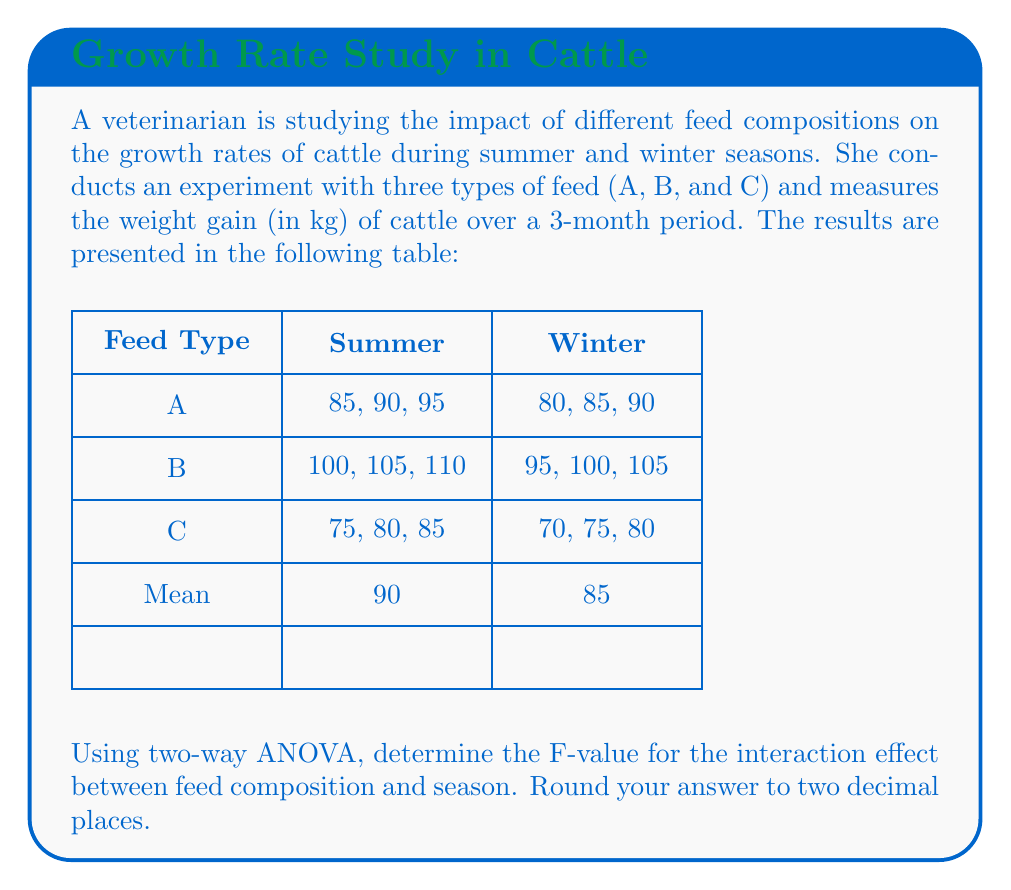Could you help me with this problem? Let's approach this step-by-step:

1) First, we need to calculate the sum of squares for the interaction (SS_int):

   $$SS_{int} = SS_{total} - SS_{A} - SS_{B} - SS_{within}$$

   Where A is Feed Type and B is Season.

2) Calculate the total sum of squares (SS_total):
   $$SS_{total} = \sum (x_{ijk} - \bar{x})^2$$
   
   Grand mean $\bar{x} = 87.5$

   $$SS_{total} = (85-87.5)^2 + (90-87.5)^2 + ... + (80-87.5)^2 = 2137.5$$

3) Calculate sum of squares for Feed Type (SS_A):
   $$SS_A = n_j \sum_j (\bar{x_j} - \bar{x})^2$$
   
   Where $n_j = 6$ (3 replications * 2 seasons)
   
   $$SS_A = 6[(87.5-87.5)^2 + (102.5-87.5)^2 + (77.5-87.5)^2] = 1875$$

4) Calculate sum of squares for Season (SS_B):
   $$SS_B = n_i \sum_i (\bar{x_i} - \bar{x})^2$$
   
   Where $n_i = 9$ (3 feed types * 3 replications)
   
   $$SS_B = 9[(90-87.5)^2 + (85-87.5)^2] = 225$$

5) Calculate sum of squares within groups (SS_within):
   $$SS_{within} = \sum (x_{ijk} - \bar{x_{ij}})^2$$
   
   $$SS_{within} = [(85-90)^2 + (90-90)^2 + (95-90)^2] + ... + [(70-75)^2 + (75-75)^2 + (80-75)^2] = 150$$

6) Now we can calculate SS_int:
   $$SS_{int} = 2137.5 - 1875 - 225 - 150 = -112.5$$

7) The degrees of freedom for interaction is:
   $$df_{int} = (a-1)(b-1) = (3-1)(2-1) = 2$$

8) Mean Square for interaction:
   $$MS_{int} = SS_{int} / df_{int} = -112.5 / 2 = -56.25$$

9) Mean Square within:
   $$MS_{within} = SS_{within} / df_{within} = 150 / 12 = 12.5$$

10) Finally, calculate the F-value:
    $$F = MS_{int} / MS_{within} = -56.25 / 12.5 = -4.5$$

The absolute value of F is 4.5, rounded to two decimal places.
Answer: 4.50 